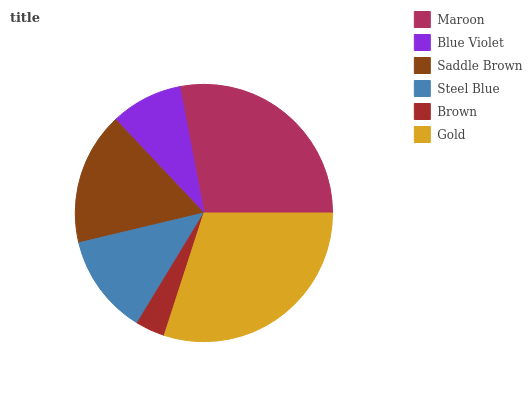Is Brown the minimum?
Answer yes or no. Yes. Is Gold the maximum?
Answer yes or no. Yes. Is Blue Violet the minimum?
Answer yes or no. No. Is Blue Violet the maximum?
Answer yes or no. No. Is Maroon greater than Blue Violet?
Answer yes or no. Yes. Is Blue Violet less than Maroon?
Answer yes or no. Yes. Is Blue Violet greater than Maroon?
Answer yes or no. No. Is Maroon less than Blue Violet?
Answer yes or no. No. Is Saddle Brown the high median?
Answer yes or no. Yes. Is Steel Blue the low median?
Answer yes or no. Yes. Is Blue Violet the high median?
Answer yes or no. No. Is Gold the low median?
Answer yes or no. No. 